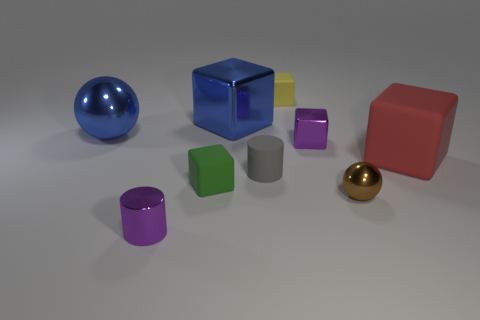How many other objects are there of the same color as the small shiny sphere?
Offer a terse response. 0. What is the size of the green block that is the same material as the big red block?
Provide a succinct answer. Small. What number of things are either purple metal things that are behind the red block or purple metal objects that are to the right of the small purple cylinder?
Your answer should be very brief. 1. Does the shiny ball that is behind the green matte thing have the same size as the gray matte cylinder?
Provide a succinct answer. No. The rubber cube on the left side of the small yellow matte thing is what color?
Offer a terse response. Green. What color is the other tiny rubber object that is the same shape as the tiny green matte thing?
Make the answer very short. Yellow. What number of blue shiny spheres are right of the tiny cube left of the tiny yellow object to the left of the red matte object?
Your answer should be very brief. 0. Are there fewer red objects behind the large red object than big yellow metal objects?
Provide a short and direct response. No. Does the tiny metallic cube have the same color as the metallic cylinder?
Offer a very short reply. Yes. What is the size of the green object that is the same shape as the yellow rubber thing?
Make the answer very short. Small. 